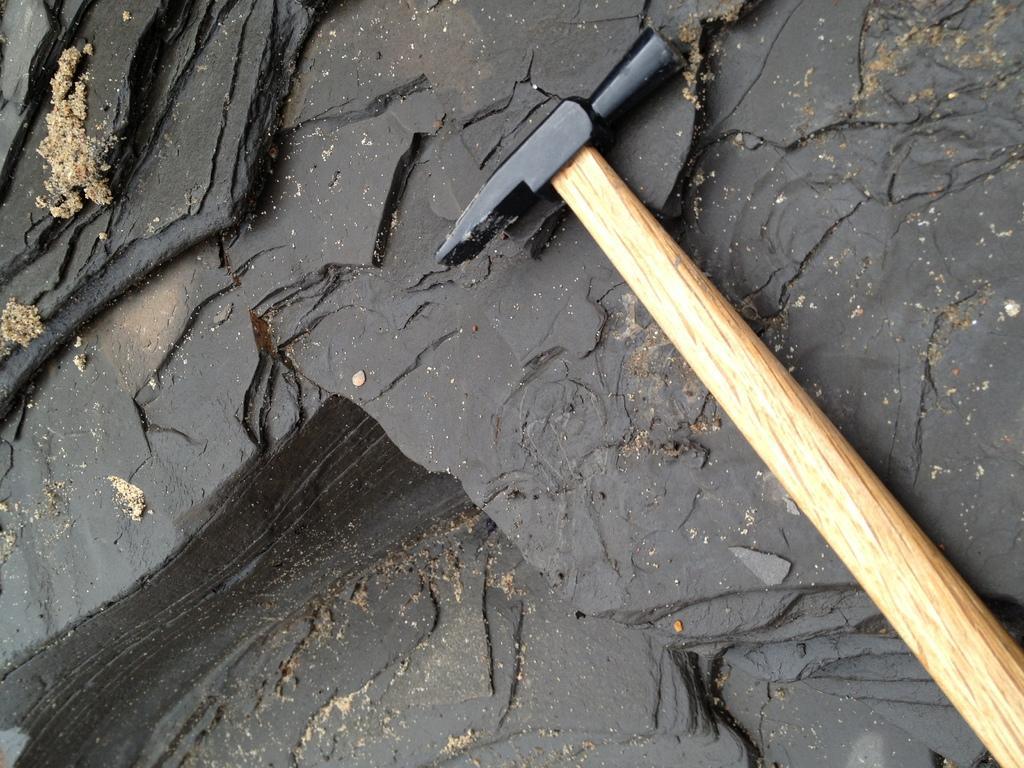How would you summarize this image in a sentence or two? In this image there is a hammer on the rock. 